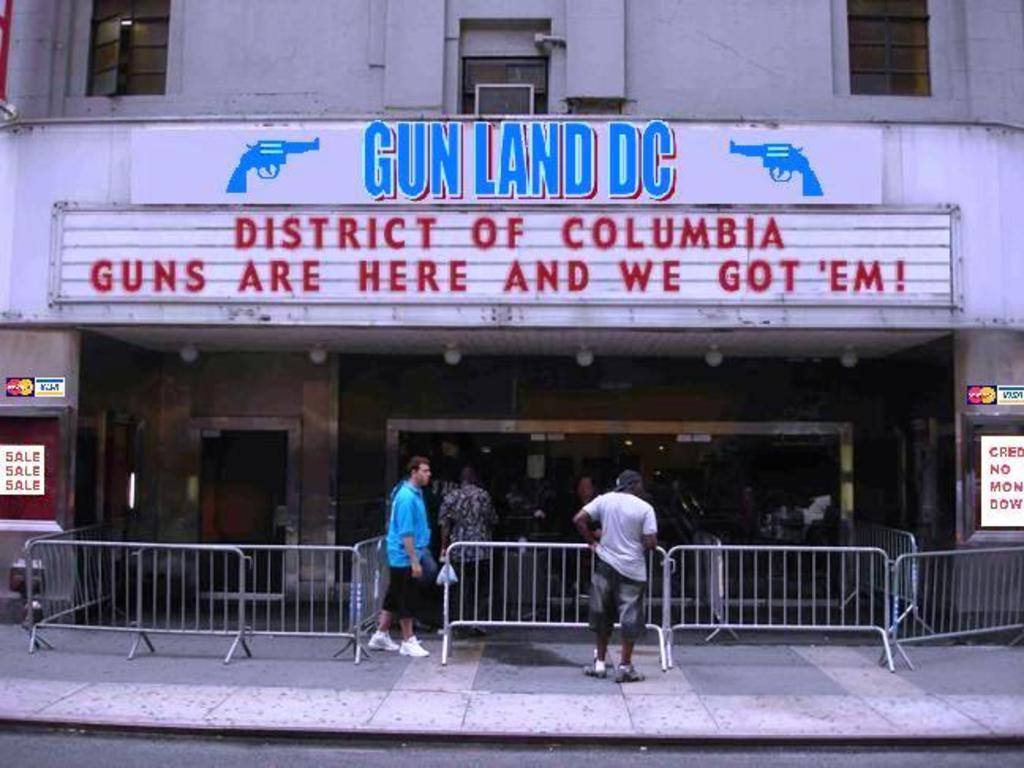What are the people in the image doing? The people in the image are standing on the footpath. What can be seen near the footpath in the image? There is a railing in the image. What type of business is visible in the image? There is a gun shop in the image. What colors are mentioned on the wall of the building in the image? There are blue and red color words on the wall of the building in the image. Can you see any holes in the image? There are no holes visible in the image. What type of fight is taking place in the image? There is no fight present in the image; it features people standing on a footpath, a railing, a gun shop, and color words on a wall. 